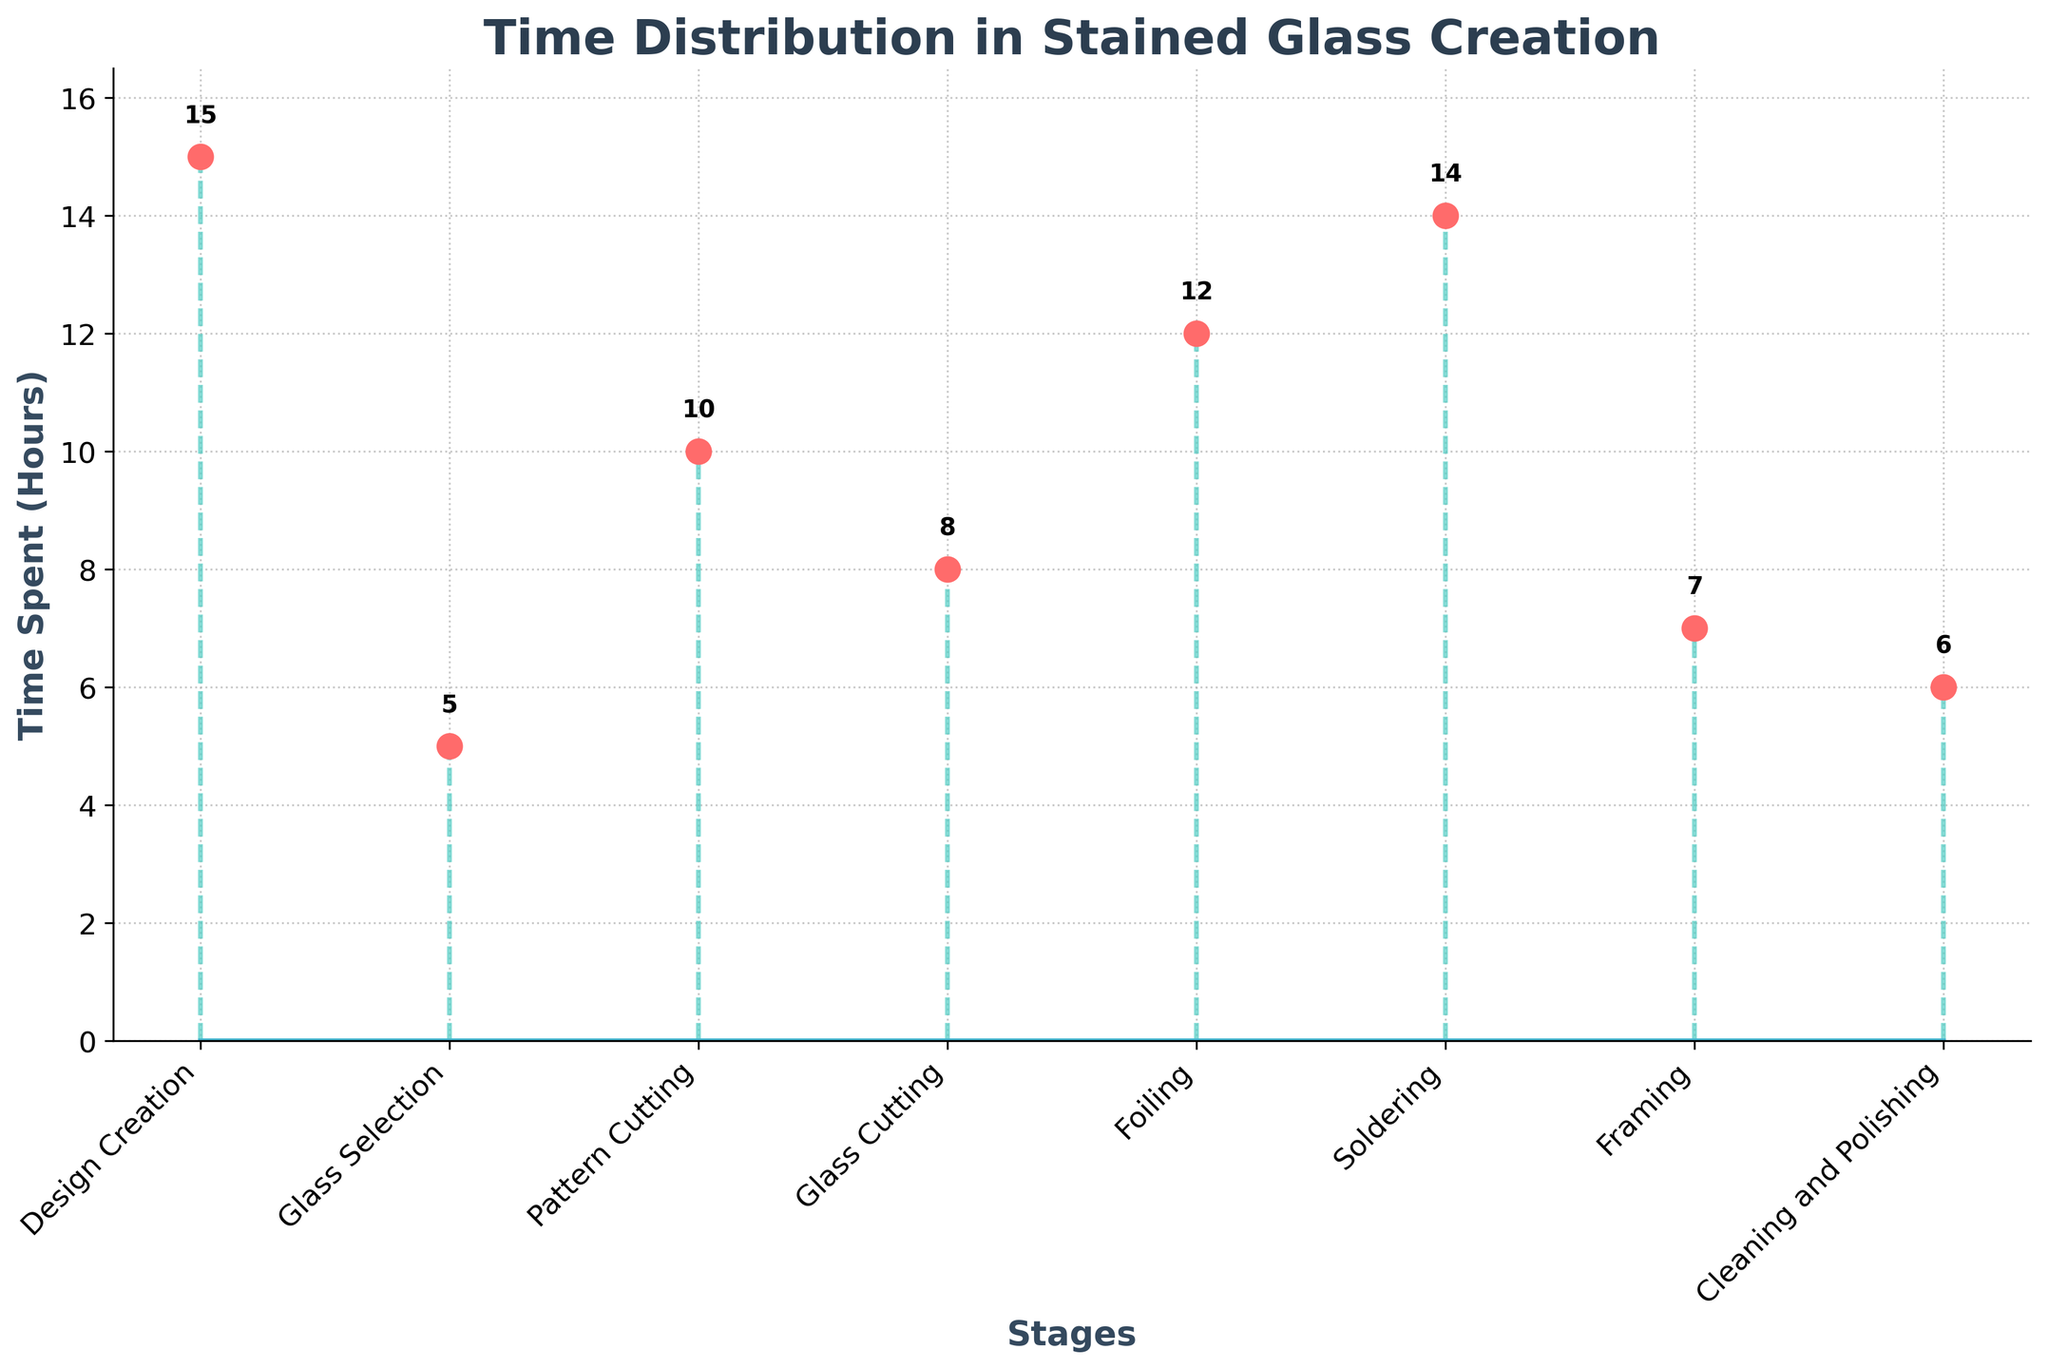What's the title of the figure? The title is written at the top of the figure and typically summarizes what the figure is about. The title here is "Time Distribution in Stained Glass Creation".
Answer: Time Distribution in Stained Glass Creation What are the labels of the X and Y axes? The X and Y axes labels are generally found below the horizontal and beside the vertical axes respectively. On this figure, the X-axis is labeled "Stages" and the Y-axis is labeled "Time Spent (Hours)".
Answer: Stages; Time Spent (Hours) Which stage takes the most time? By looking at the highest point on the plot, you can see that the "Design Creation" stage has the tallest marker, indicating the most time spent.
Answer: Design Creation How much time is spent on Cleaning and Polishing? The marker for "Cleaning and Polishing" shows how much time is spent on this stage. It's labeled with its value directly on the plot.
Answer: 6 hours What's the difference in time spent between Glass Cutting and pattern cutting? The time spent on "Glass Cutting" is 8 hours, and on "Pattern Cutting" is 10 hours. The difference between these times is 10 - 8 = 2 hours.
Answer: 2 hours Which stages have a time difference of less than 2 hours? You need to compare the time spent on each stage with its neighboring stage(s) to find the differences that are less than 2 hours. "Cleaning and Polishing" (6 hours) and "Framing" (7 hours), and "Foiling" (12 hours) and "Soldering" (14 hours) fit this criteria.
Answer: Cleaning and Polishing, Framing; Foiling, Soldering On average, how much time is spent on each stage? Sum up the total time spent on all stages and divide by the number of stages. The total time is 15 + 5 + 10 + 8 + 12 + 14 + 7 + 6 = 77 hours. There are 8 stages, so the average time spent is 77 / 8 ≈ 9.625 hours.
Answer: 9.625 hours What’s the median time spent on the stages? To find the median, arrange the times in ascending order: 5, 6, 7, 8, 10, 12, 14, 15. The median is the average of the 4th and 5th values (8 and 10), so the median is (8 + 10) / 2 = 9 hours.
Answer: 9 hours How many stages take more than 10 hours? Count the number of stages where the time value exceeds 10 hours: "Design Creation" (15), "Foiling" (12), "Soldering" (14), which makes 3 stages.
Answer: 3 stages What is the unique feature of stem plots visible in this figure? A unique feature of stem plots are the vertical lines (stems) and markers which show individual data points distinctly. This figure displays stems and markers connecting each stage to their respective time values.
Answer: Vertical lines (stems) and markers 